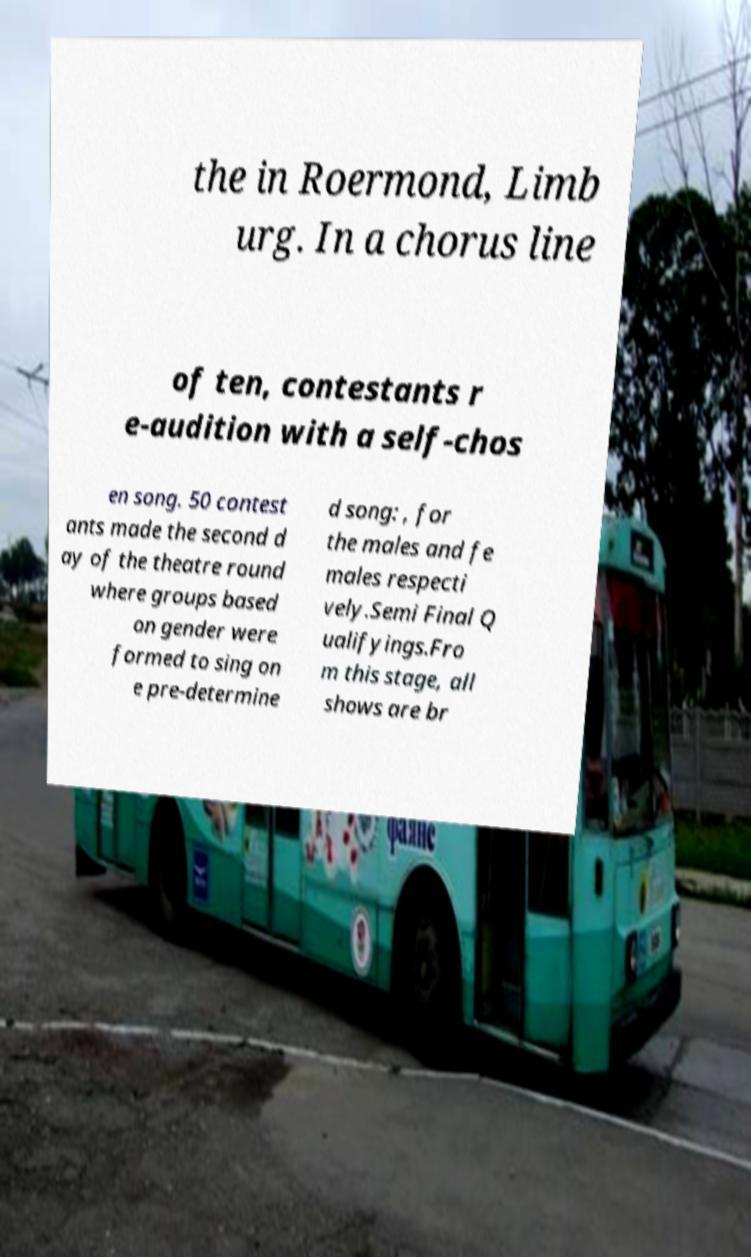Could you assist in decoding the text presented in this image and type it out clearly? the in Roermond, Limb urg. In a chorus line of ten, contestants r e-audition with a self-chos en song. 50 contest ants made the second d ay of the theatre round where groups based on gender were formed to sing on e pre-determine d song: , for the males and fe males respecti vely.Semi Final Q ualifyings.Fro m this stage, all shows are br 